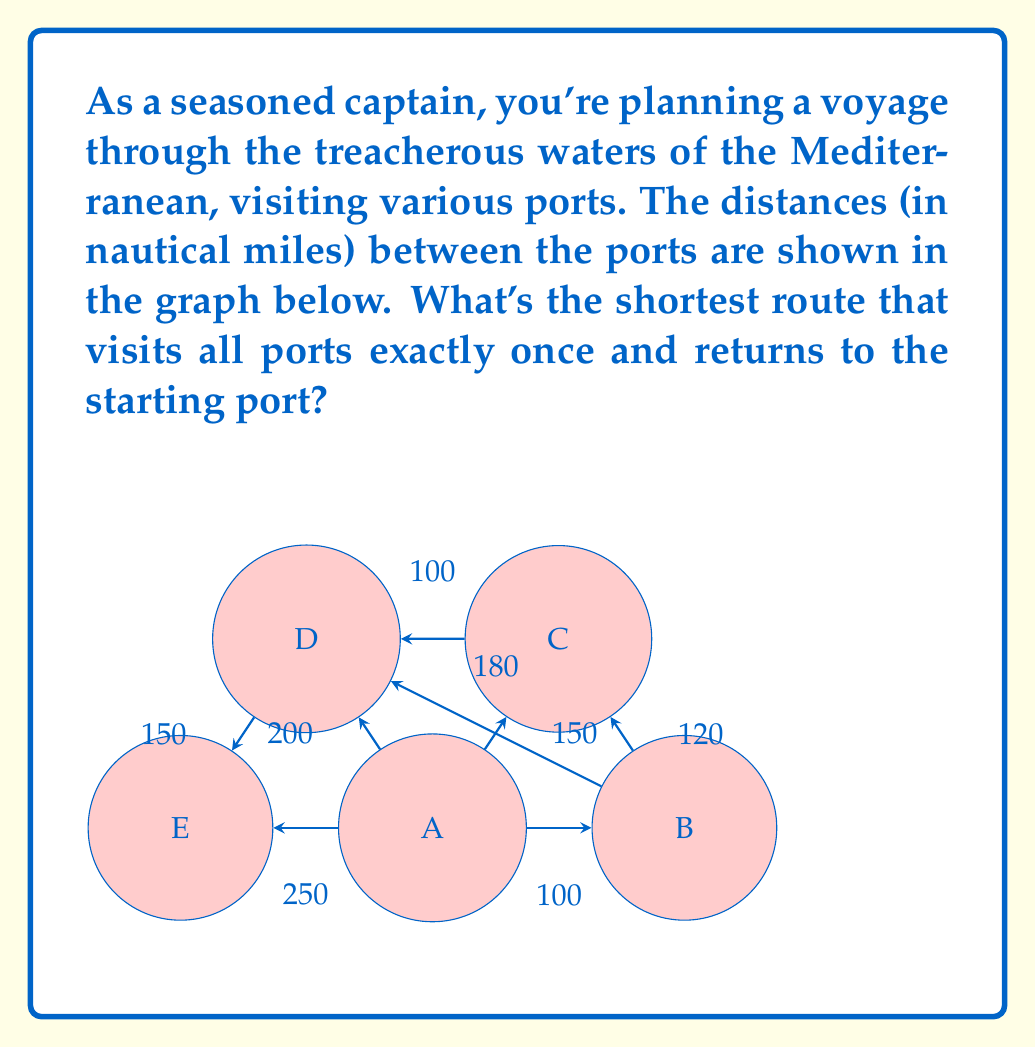Can you answer this question? To solve this problem, we need to find the Hamiltonian cycle with the minimum total weight in the given graph. This is known as the Traveling Salesman Problem (TSP), which is NP-hard. For small graphs like this, we can use a brute-force approach:

1) List all possible Hamiltonian cycles:
   A-B-C-D-E-A
   A-B-D-C-E-A
   A-C-B-D-E-A
   A-C-D-B-E-A
   A-D-B-C-E-A
   A-D-C-B-E-A

2) Calculate the total distance for each cycle:

   A-B-C-D-E-A: 
   $100 + 120 + 100 + 150 + 250 = 720$

   A-B-D-C-E-A: 
   $100 + 180 + 100 + 150 + 250 = 780$

   A-C-B-D-E-A: 
   $150 + 120 + 180 + 150 + 250 = 850$

   A-C-D-B-E-A: 
   $150 + 100 + 180 + 250 = 680$

   A-D-B-C-E-A: 
   $200 + 180 + 120 + 150 + 250 = 900$

   A-D-C-B-E-A: 
   $200 + 100 + 120 + 250 = 670$

3) The shortest path is A-D-C-B-E-A with a total distance of 670 nautical miles.

This method, while guaranteed to find the optimal solution, becomes impractical for larger graphs due to its exponential time complexity. For real-world applications with many ports, heuristic algorithms like the Nearest Neighbor or more advanced techniques like Genetic Algorithms are often used to find near-optimal solutions in reasonable time.
Answer: A-D-C-B-E-A, 670 nautical miles 